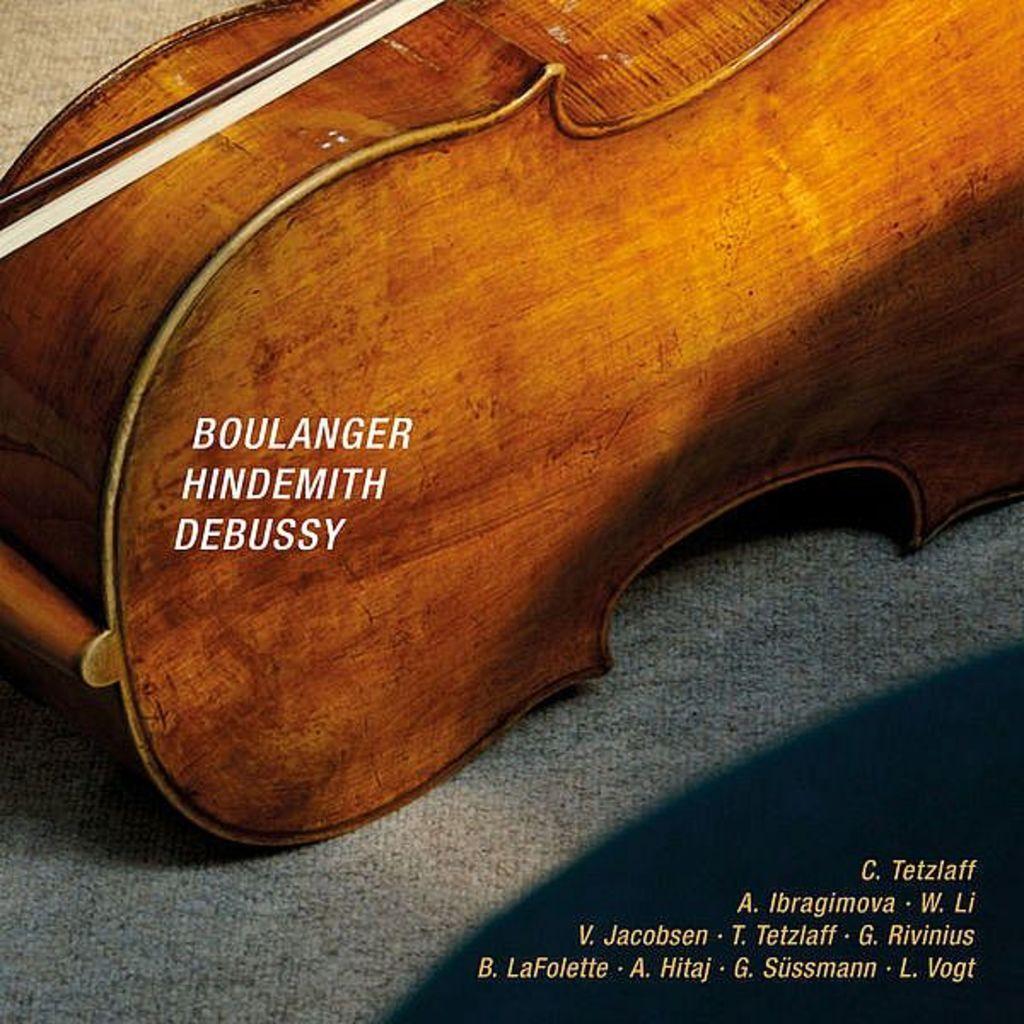How would you summarize this image in a sentence or two? In this image I see a wooden box and there are words over here. 